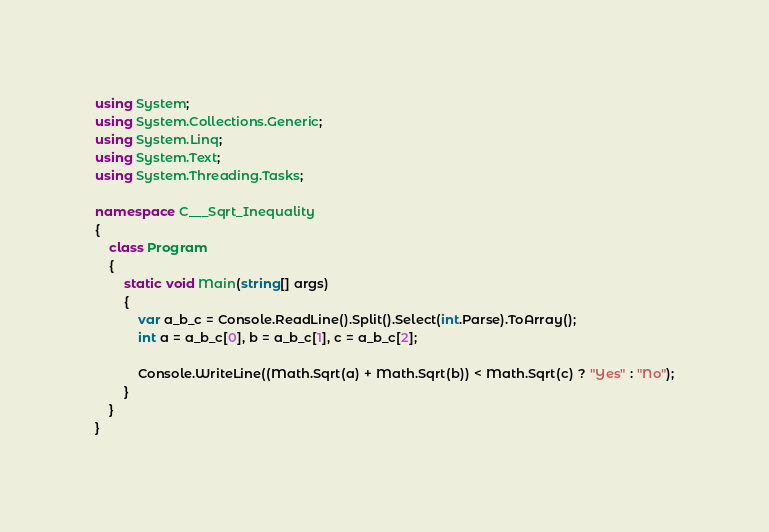Convert code to text. <code><loc_0><loc_0><loc_500><loc_500><_C#_>using System;
using System.Collections.Generic;
using System.Linq;
using System.Text;
using System.Threading.Tasks;

namespace C___Sqrt_Inequality
{
    class Program
    {
        static void Main(string[] args)
        {
            var a_b_c = Console.ReadLine().Split().Select(int.Parse).ToArray();
            int a = a_b_c[0], b = a_b_c[1], c = a_b_c[2];

            Console.WriteLine((Math.Sqrt(a) + Math.Sqrt(b)) < Math.Sqrt(c) ? "Yes" : "No");
        }
    }
}
</code> 